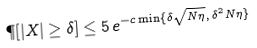Convert formula to latex. <formula><loc_0><loc_0><loc_500><loc_500>\P [ | X | \geq \delta ] \leq 5 \, e ^ { - c \min \{ \delta \sqrt { N \eta } , \, \delta ^ { 2 } N \eta \} }</formula> 